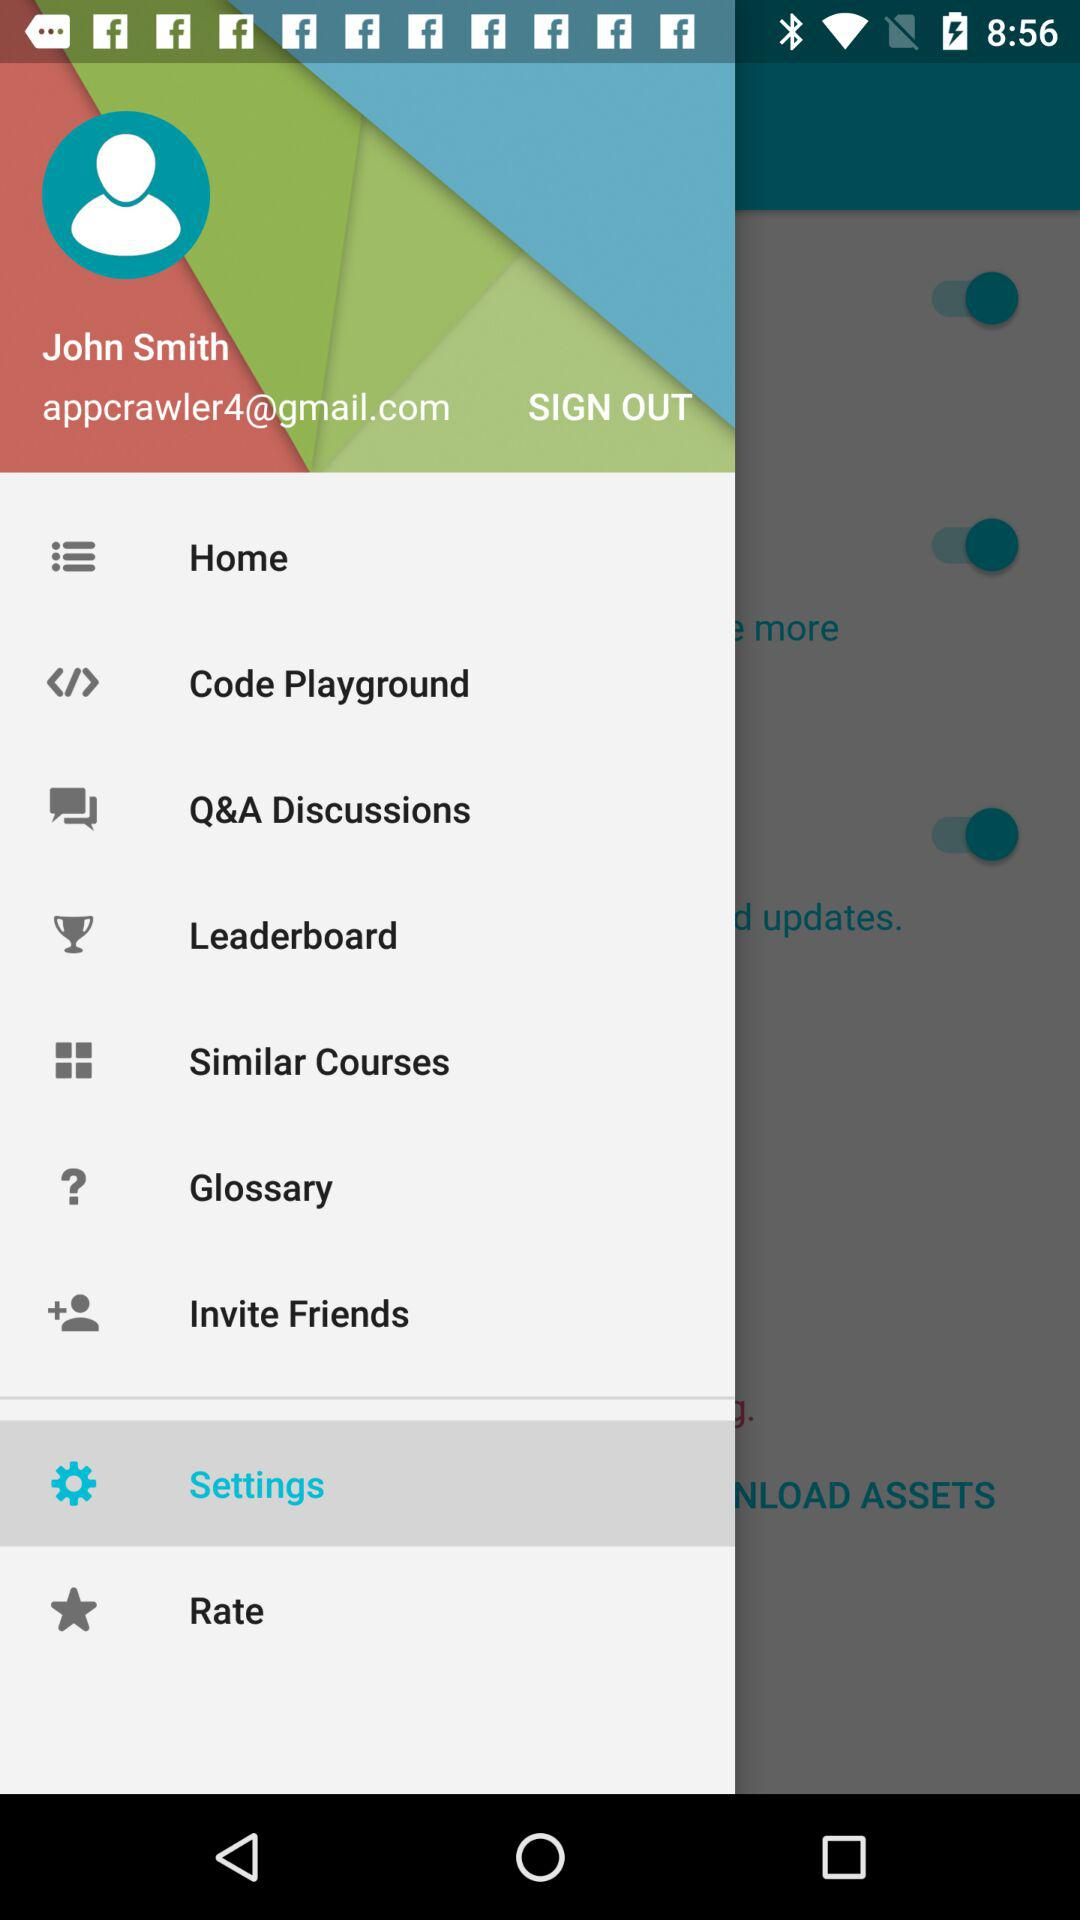What is the name of the user? The name of the user is John Smith. 